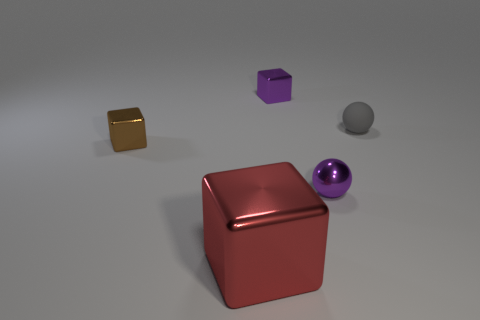Are there any other things that are the same size as the red object?
Offer a terse response. No. There is a small brown thing that is the same shape as the red thing; what is it made of?
Keep it short and to the point. Metal. Is the number of small brown metal blocks behind the purple metal cube the same as the number of tiny green cubes?
Your answer should be compact. Yes. Are there any tiny cubes of the same color as the tiny shiny ball?
Ensure brevity in your answer.  Yes. Do the purple metallic cube and the purple metal sphere have the same size?
Your answer should be compact. Yes. What size is the ball behind the purple ball that is to the left of the tiny gray matte ball?
Your answer should be compact. Small. There is a metallic thing that is behind the purple sphere and on the left side of the tiny purple metallic block; what is its size?
Make the answer very short. Small. What number of metal things have the same size as the gray matte sphere?
Your response must be concise. 3. What number of rubber objects are tiny blue cylinders or purple blocks?
Offer a terse response. 0. The block that is the same color as the small metal ball is what size?
Offer a very short reply. Small. 